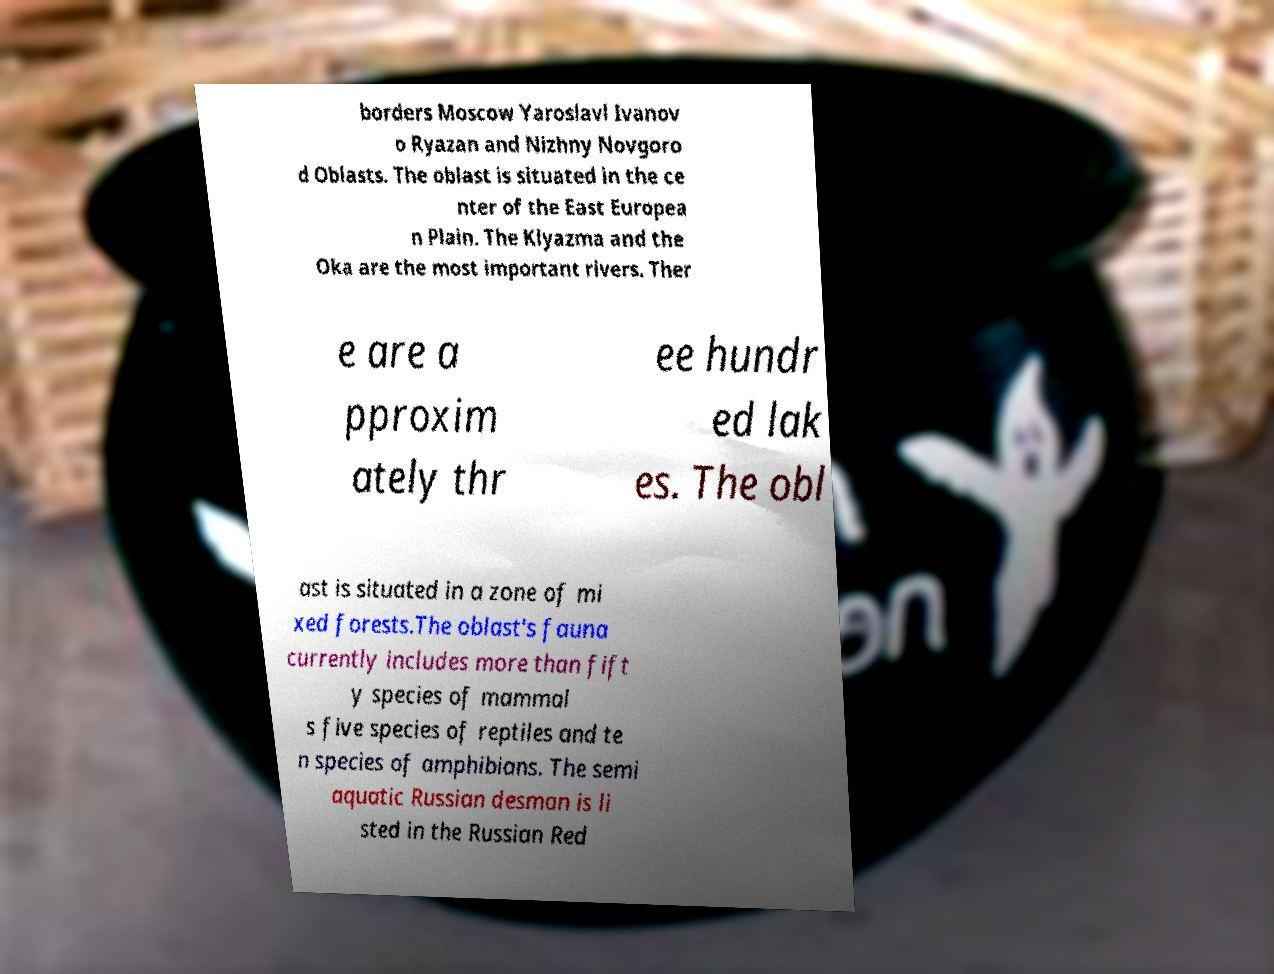Can you read and provide the text displayed in the image?This photo seems to have some interesting text. Can you extract and type it out for me? borders Moscow Yaroslavl Ivanov o Ryazan and Nizhny Novgoro d Oblasts. The oblast is situated in the ce nter of the East Europea n Plain. The Klyazma and the Oka are the most important rivers. Ther e are a pproxim ately thr ee hundr ed lak es. The obl ast is situated in a zone of mi xed forests.The oblast's fauna currently includes more than fift y species of mammal s five species of reptiles and te n species of amphibians. The semi aquatic Russian desman is li sted in the Russian Red 